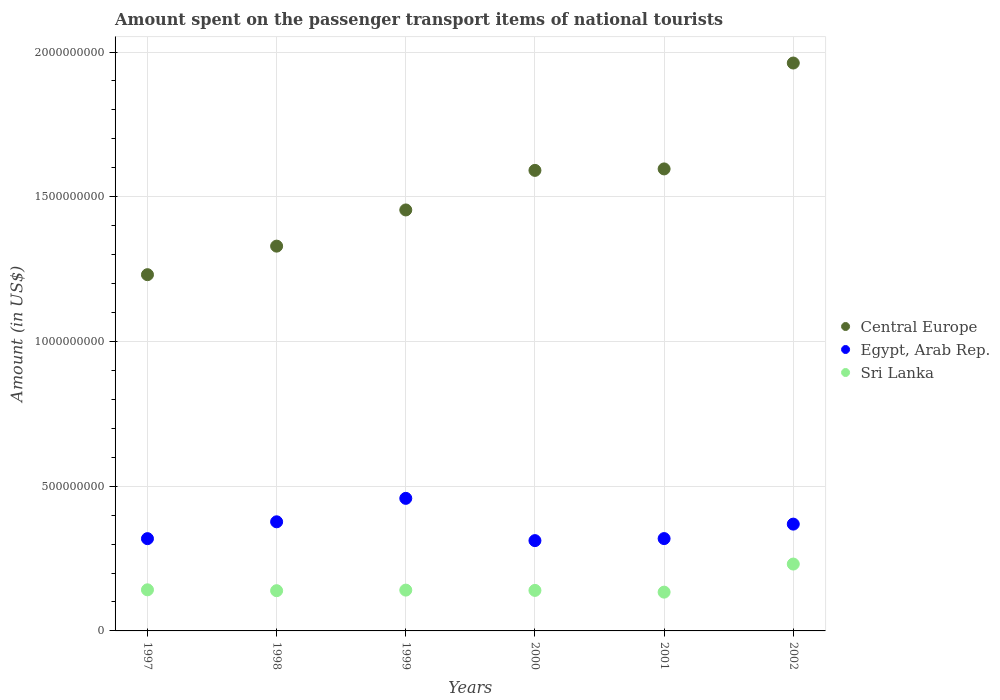How many different coloured dotlines are there?
Provide a succinct answer. 3. Is the number of dotlines equal to the number of legend labels?
Offer a very short reply. Yes. What is the amount spent on the passenger transport items of national tourists in Central Europe in 1999?
Give a very brief answer. 1.45e+09. Across all years, what is the maximum amount spent on the passenger transport items of national tourists in Sri Lanka?
Provide a short and direct response. 2.31e+08. Across all years, what is the minimum amount spent on the passenger transport items of national tourists in Central Europe?
Keep it short and to the point. 1.23e+09. What is the total amount spent on the passenger transport items of national tourists in Sri Lanka in the graph?
Give a very brief answer. 9.27e+08. What is the difference between the amount spent on the passenger transport items of national tourists in Egypt, Arab Rep. in 2000 and that in 2002?
Your answer should be very brief. -5.70e+07. What is the difference between the amount spent on the passenger transport items of national tourists in Egypt, Arab Rep. in 1997 and the amount spent on the passenger transport items of national tourists in Central Europe in 2000?
Your answer should be compact. -1.27e+09. What is the average amount spent on the passenger transport items of national tourists in Sri Lanka per year?
Provide a short and direct response. 1.54e+08. In the year 2001, what is the difference between the amount spent on the passenger transport items of national tourists in Egypt, Arab Rep. and amount spent on the passenger transport items of national tourists in Sri Lanka?
Offer a terse response. 1.85e+08. What is the ratio of the amount spent on the passenger transport items of national tourists in Sri Lanka in 1998 to that in 2000?
Ensure brevity in your answer.  0.99. Is the difference between the amount spent on the passenger transport items of national tourists in Egypt, Arab Rep. in 1998 and 2000 greater than the difference between the amount spent on the passenger transport items of national tourists in Sri Lanka in 1998 and 2000?
Ensure brevity in your answer.  Yes. What is the difference between the highest and the second highest amount spent on the passenger transport items of national tourists in Sri Lanka?
Provide a short and direct response. 8.90e+07. What is the difference between the highest and the lowest amount spent on the passenger transport items of national tourists in Egypt, Arab Rep.?
Make the answer very short. 1.46e+08. Is the sum of the amount spent on the passenger transport items of national tourists in Sri Lanka in 2000 and 2002 greater than the maximum amount spent on the passenger transport items of national tourists in Egypt, Arab Rep. across all years?
Provide a succinct answer. No. Is the amount spent on the passenger transport items of national tourists in Central Europe strictly less than the amount spent on the passenger transport items of national tourists in Egypt, Arab Rep. over the years?
Your answer should be compact. No. How many years are there in the graph?
Provide a short and direct response. 6. Does the graph contain grids?
Keep it short and to the point. Yes. Where does the legend appear in the graph?
Ensure brevity in your answer.  Center right. How many legend labels are there?
Your answer should be very brief. 3. What is the title of the graph?
Provide a short and direct response. Amount spent on the passenger transport items of national tourists. What is the label or title of the X-axis?
Offer a very short reply. Years. What is the label or title of the Y-axis?
Your response must be concise. Amount (in US$). What is the Amount (in US$) in Central Europe in 1997?
Your answer should be compact. 1.23e+09. What is the Amount (in US$) in Egypt, Arab Rep. in 1997?
Your answer should be compact. 3.19e+08. What is the Amount (in US$) in Sri Lanka in 1997?
Your answer should be compact. 1.42e+08. What is the Amount (in US$) in Central Europe in 1998?
Offer a very short reply. 1.33e+09. What is the Amount (in US$) in Egypt, Arab Rep. in 1998?
Offer a very short reply. 3.77e+08. What is the Amount (in US$) of Sri Lanka in 1998?
Your answer should be very brief. 1.39e+08. What is the Amount (in US$) of Central Europe in 1999?
Provide a succinct answer. 1.45e+09. What is the Amount (in US$) in Egypt, Arab Rep. in 1999?
Make the answer very short. 4.58e+08. What is the Amount (in US$) of Sri Lanka in 1999?
Ensure brevity in your answer.  1.41e+08. What is the Amount (in US$) in Central Europe in 2000?
Make the answer very short. 1.59e+09. What is the Amount (in US$) of Egypt, Arab Rep. in 2000?
Your response must be concise. 3.12e+08. What is the Amount (in US$) in Sri Lanka in 2000?
Keep it short and to the point. 1.40e+08. What is the Amount (in US$) of Central Europe in 2001?
Keep it short and to the point. 1.60e+09. What is the Amount (in US$) in Egypt, Arab Rep. in 2001?
Your response must be concise. 3.19e+08. What is the Amount (in US$) of Sri Lanka in 2001?
Offer a very short reply. 1.34e+08. What is the Amount (in US$) in Central Europe in 2002?
Provide a short and direct response. 1.96e+09. What is the Amount (in US$) of Egypt, Arab Rep. in 2002?
Your response must be concise. 3.69e+08. What is the Amount (in US$) in Sri Lanka in 2002?
Keep it short and to the point. 2.31e+08. Across all years, what is the maximum Amount (in US$) in Central Europe?
Your answer should be compact. 1.96e+09. Across all years, what is the maximum Amount (in US$) of Egypt, Arab Rep.?
Provide a succinct answer. 4.58e+08. Across all years, what is the maximum Amount (in US$) of Sri Lanka?
Your response must be concise. 2.31e+08. Across all years, what is the minimum Amount (in US$) of Central Europe?
Make the answer very short. 1.23e+09. Across all years, what is the minimum Amount (in US$) of Egypt, Arab Rep.?
Your answer should be very brief. 3.12e+08. Across all years, what is the minimum Amount (in US$) in Sri Lanka?
Provide a short and direct response. 1.34e+08. What is the total Amount (in US$) of Central Europe in the graph?
Provide a short and direct response. 9.16e+09. What is the total Amount (in US$) of Egypt, Arab Rep. in the graph?
Ensure brevity in your answer.  2.15e+09. What is the total Amount (in US$) of Sri Lanka in the graph?
Your answer should be compact. 9.27e+08. What is the difference between the Amount (in US$) of Central Europe in 1997 and that in 1998?
Provide a succinct answer. -9.86e+07. What is the difference between the Amount (in US$) in Egypt, Arab Rep. in 1997 and that in 1998?
Offer a very short reply. -5.82e+07. What is the difference between the Amount (in US$) of Sri Lanka in 1997 and that in 1998?
Keep it short and to the point. 3.00e+06. What is the difference between the Amount (in US$) in Central Europe in 1997 and that in 1999?
Your answer should be very brief. -2.24e+08. What is the difference between the Amount (in US$) of Egypt, Arab Rep. in 1997 and that in 1999?
Make the answer very short. -1.39e+08. What is the difference between the Amount (in US$) of Sri Lanka in 1997 and that in 1999?
Provide a short and direct response. 1.00e+06. What is the difference between the Amount (in US$) of Central Europe in 1997 and that in 2000?
Give a very brief answer. -3.60e+08. What is the difference between the Amount (in US$) in Egypt, Arab Rep. in 1997 and that in 2000?
Your response must be concise. 6.80e+06. What is the difference between the Amount (in US$) in Central Europe in 1997 and that in 2001?
Offer a terse response. -3.65e+08. What is the difference between the Amount (in US$) of Egypt, Arab Rep. in 1997 and that in 2001?
Ensure brevity in your answer.  -2.00e+05. What is the difference between the Amount (in US$) in Central Europe in 1997 and that in 2002?
Ensure brevity in your answer.  -7.31e+08. What is the difference between the Amount (in US$) in Egypt, Arab Rep. in 1997 and that in 2002?
Give a very brief answer. -5.02e+07. What is the difference between the Amount (in US$) in Sri Lanka in 1997 and that in 2002?
Provide a succinct answer. -8.90e+07. What is the difference between the Amount (in US$) of Central Europe in 1998 and that in 1999?
Offer a terse response. -1.25e+08. What is the difference between the Amount (in US$) of Egypt, Arab Rep. in 1998 and that in 1999?
Offer a very short reply. -8.10e+07. What is the difference between the Amount (in US$) in Sri Lanka in 1998 and that in 1999?
Your answer should be very brief. -2.00e+06. What is the difference between the Amount (in US$) of Central Europe in 1998 and that in 2000?
Your answer should be compact. -2.62e+08. What is the difference between the Amount (in US$) of Egypt, Arab Rep. in 1998 and that in 2000?
Make the answer very short. 6.50e+07. What is the difference between the Amount (in US$) of Sri Lanka in 1998 and that in 2000?
Ensure brevity in your answer.  -1.00e+06. What is the difference between the Amount (in US$) of Central Europe in 1998 and that in 2001?
Offer a very short reply. -2.67e+08. What is the difference between the Amount (in US$) of Egypt, Arab Rep. in 1998 and that in 2001?
Your response must be concise. 5.80e+07. What is the difference between the Amount (in US$) in Central Europe in 1998 and that in 2002?
Offer a very short reply. -6.33e+08. What is the difference between the Amount (in US$) of Sri Lanka in 1998 and that in 2002?
Your answer should be very brief. -9.20e+07. What is the difference between the Amount (in US$) of Central Europe in 1999 and that in 2000?
Ensure brevity in your answer.  -1.37e+08. What is the difference between the Amount (in US$) of Egypt, Arab Rep. in 1999 and that in 2000?
Offer a terse response. 1.46e+08. What is the difference between the Amount (in US$) of Central Europe in 1999 and that in 2001?
Ensure brevity in your answer.  -1.42e+08. What is the difference between the Amount (in US$) of Egypt, Arab Rep. in 1999 and that in 2001?
Provide a succinct answer. 1.39e+08. What is the difference between the Amount (in US$) of Sri Lanka in 1999 and that in 2001?
Make the answer very short. 7.00e+06. What is the difference between the Amount (in US$) in Central Europe in 1999 and that in 2002?
Your answer should be compact. -5.08e+08. What is the difference between the Amount (in US$) in Egypt, Arab Rep. in 1999 and that in 2002?
Provide a short and direct response. 8.90e+07. What is the difference between the Amount (in US$) of Sri Lanka in 1999 and that in 2002?
Your answer should be compact. -9.00e+07. What is the difference between the Amount (in US$) of Central Europe in 2000 and that in 2001?
Keep it short and to the point. -5.06e+06. What is the difference between the Amount (in US$) in Egypt, Arab Rep. in 2000 and that in 2001?
Your response must be concise. -7.00e+06. What is the difference between the Amount (in US$) in Sri Lanka in 2000 and that in 2001?
Offer a terse response. 6.00e+06. What is the difference between the Amount (in US$) of Central Europe in 2000 and that in 2002?
Provide a short and direct response. -3.71e+08. What is the difference between the Amount (in US$) in Egypt, Arab Rep. in 2000 and that in 2002?
Your response must be concise. -5.70e+07. What is the difference between the Amount (in US$) of Sri Lanka in 2000 and that in 2002?
Your response must be concise. -9.10e+07. What is the difference between the Amount (in US$) in Central Europe in 2001 and that in 2002?
Provide a succinct answer. -3.66e+08. What is the difference between the Amount (in US$) in Egypt, Arab Rep. in 2001 and that in 2002?
Your answer should be compact. -5.00e+07. What is the difference between the Amount (in US$) of Sri Lanka in 2001 and that in 2002?
Your answer should be compact. -9.70e+07. What is the difference between the Amount (in US$) of Central Europe in 1997 and the Amount (in US$) of Egypt, Arab Rep. in 1998?
Provide a short and direct response. 8.54e+08. What is the difference between the Amount (in US$) in Central Europe in 1997 and the Amount (in US$) in Sri Lanka in 1998?
Ensure brevity in your answer.  1.09e+09. What is the difference between the Amount (in US$) of Egypt, Arab Rep. in 1997 and the Amount (in US$) of Sri Lanka in 1998?
Your answer should be very brief. 1.80e+08. What is the difference between the Amount (in US$) of Central Europe in 1997 and the Amount (in US$) of Egypt, Arab Rep. in 1999?
Keep it short and to the point. 7.73e+08. What is the difference between the Amount (in US$) of Central Europe in 1997 and the Amount (in US$) of Sri Lanka in 1999?
Keep it short and to the point. 1.09e+09. What is the difference between the Amount (in US$) of Egypt, Arab Rep. in 1997 and the Amount (in US$) of Sri Lanka in 1999?
Keep it short and to the point. 1.78e+08. What is the difference between the Amount (in US$) of Central Europe in 1997 and the Amount (in US$) of Egypt, Arab Rep. in 2000?
Provide a short and direct response. 9.19e+08. What is the difference between the Amount (in US$) in Central Europe in 1997 and the Amount (in US$) in Sri Lanka in 2000?
Provide a succinct answer. 1.09e+09. What is the difference between the Amount (in US$) in Egypt, Arab Rep. in 1997 and the Amount (in US$) in Sri Lanka in 2000?
Make the answer very short. 1.79e+08. What is the difference between the Amount (in US$) in Central Europe in 1997 and the Amount (in US$) in Egypt, Arab Rep. in 2001?
Your response must be concise. 9.12e+08. What is the difference between the Amount (in US$) in Central Europe in 1997 and the Amount (in US$) in Sri Lanka in 2001?
Offer a very short reply. 1.10e+09. What is the difference between the Amount (in US$) in Egypt, Arab Rep. in 1997 and the Amount (in US$) in Sri Lanka in 2001?
Offer a very short reply. 1.85e+08. What is the difference between the Amount (in US$) in Central Europe in 1997 and the Amount (in US$) in Egypt, Arab Rep. in 2002?
Provide a succinct answer. 8.62e+08. What is the difference between the Amount (in US$) of Central Europe in 1997 and the Amount (in US$) of Sri Lanka in 2002?
Provide a succinct answer. 1.00e+09. What is the difference between the Amount (in US$) of Egypt, Arab Rep. in 1997 and the Amount (in US$) of Sri Lanka in 2002?
Keep it short and to the point. 8.78e+07. What is the difference between the Amount (in US$) in Central Europe in 1998 and the Amount (in US$) in Egypt, Arab Rep. in 1999?
Offer a terse response. 8.71e+08. What is the difference between the Amount (in US$) of Central Europe in 1998 and the Amount (in US$) of Sri Lanka in 1999?
Give a very brief answer. 1.19e+09. What is the difference between the Amount (in US$) in Egypt, Arab Rep. in 1998 and the Amount (in US$) in Sri Lanka in 1999?
Provide a succinct answer. 2.36e+08. What is the difference between the Amount (in US$) of Central Europe in 1998 and the Amount (in US$) of Egypt, Arab Rep. in 2000?
Give a very brief answer. 1.02e+09. What is the difference between the Amount (in US$) of Central Europe in 1998 and the Amount (in US$) of Sri Lanka in 2000?
Give a very brief answer. 1.19e+09. What is the difference between the Amount (in US$) of Egypt, Arab Rep. in 1998 and the Amount (in US$) of Sri Lanka in 2000?
Make the answer very short. 2.37e+08. What is the difference between the Amount (in US$) in Central Europe in 1998 and the Amount (in US$) in Egypt, Arab Rep. in 2001?
Your response must be concise. 1.01e+09. What is the difference between the Amount (in US$) in Central Europe in 1998 and the Amount (in US$) in Sri Lanka in 2001?
Ensure brevity in your answer.  1.20e+09. What is the difference between the Amount (in US$) in Egypt, Arab Rep. in 1998 and the Amount (in US$) in Sri Lanka in 2001?
Offer a terse response. 2.43e+08. What is the difference between the Amount (in US$) in Central Europe in 1998 and the Amount (in US$) in Egypt, Arab Rep. in 2002?
Give a very brief answer. 9.60e+08. What is the difference between the Amount (in US$) of Central Europe in 1998 and the Amount (in US$) of Sri Lanka in 2002?
Offer a terse response. 1.10e+09. What is the difference between the Amount (in US$) of Egypt, Arab Rep. in 1998 and the Amount (in US$) of Sri Lanka in 2002?
Make the answer very short. 1.46e+08. What is the difference between the Amount (in US$) in Central Europe in 1999 and the Amount (in US$) in Egypt, Arab Rep. in 2000?
Offer a very short reply. 1.14e+09. What is the difference between the Amount (in US$) in Central Europe in 1999 and the Amount (in US$) in Sri Lanka in 2000?
Provide a succinct answer. 1.31e+09. What is the difference between the Amount (in US$) in Egypt, Arab Rep. in 1999 and the Amount (in US$) in Sri Lanka in 2000?
Make the answer very short. 3.18e+08. What is the difference between the Amount (in US$) in Central Europe in 1999 and the Amount (in US$) in Egypt, Arab Rep. in 2001?
Make the answer very short. 1.14e+09. What is the difference between the Amount (in US$) of Central Europe in 1999 and the Amount (in US$) of Sri Lanka in 2001?
Ensure brevity in your answer.  1.32e+09. What is the difference between the Amount (in US$) in Egypt, Arab Rep. in 1999 and the Amount (in US$) in Sri Lanka in 2001?
Ensure brevity in your answer.  3.24e+08. What is the difference between the Amount (in US$) of Central Europe in 1999 and the Amount (in US$) of Egypt, Arab Rep. in 2002?
Offer a very short reply. 1.09e+09. What is the difference between the Amount (in US$) of Central Europe in 1999 and the Amount (in US$) of Sri Lanka in 2002?
Offer a very short reply. 1.22e+09. What is the difference between the Amount (in US$) of Egypt, Arab Rep. in 1999 and the Amount (in US$) of Sri Lanka in 2002?
Your answer should be very brief. 2.27e+08. What is the difference between the Amount (in US$) in Central Europe in 2000 and the Amount (in US$) in Egypt, Arab Rep. in 2001?
Ensure brevity in your answer.  1.27e+09. What is the difference between the Amount (in US$) in Central Europe in 2000 and the Amount (in US$) in Sri Lanka in 2001?
Keep it short and to the point. 1.46e+09. What is the difference between the Amount (in US$) in Egypt, Arab Rep. in 2000 and the Amount (in US$) in Sri Lanka in 2001?
Your response must be concise. 1.78e+08. What is the difference between the Amount (in US$) in Central Europe in 2000 and the Amount (in US$) in Egypt, Arab Rep. in 2002?
Give a very brief answer. 1.22e+09. What is the difference between the Amount (in US$) in Central Europe in 2000 and the Amount (in US$) in Sri Lanka in 2002?
Offer a terse response. 1.36e+09. What is the difference between the Amount (in US$) of Egypt, Arab Rep. in 2000 and the Amount (in US$) of Sri Lanka in 2002?
Give a very brief answer. 8.10e+07. What is the difference between the Amount (in US$) of Central Europe in 2001 and the Amount (in US$) of Egypt, Arab Rep. in 2002?
Offer a very short reply. 1.23e+09. What is the difference between the Amount (in US$) in Central Europe in 2001 and the Amount (in US$) in Sri Lanka in 2002?
Your response must be concise. 1.37e+09. What is the difference between the Amount (in US$) in Egypt, Arab Rep. in 2001 and the Amount (in US$) in Sri Lanka in 2002?
Keep it short and to the point. 8.80e+07. What is the average Amount (in US$) of Central Europe per year?
Make the answer very short. 1.53e+09. What is the average Amount (in US$) of Egypt, Arab Rep. per year?
Provide a succinct answer. 3.59e+08. What is the average Amount (in US$) in Sri Lanka per year?
Give a very brief answer. 1.54e+08. In the year 1997, what is the difference between the Amount (in US$) in Central Europe and Amount (in US$) in Egypt, Arab Rep.?
Provide a short and direct response. 9.12e+08. In the year 1997, what is the difference between the Amount (in US$) of Central Europe and Amount (in US$) of Sri Lanka?
Your response must be concise. 1.09e+09. In the year 1997, what is the difference between the Amount (in US$) of Egypt, Arab Rep. and Amount (in US$) of Sri Lanka?
Provide a succinct answer. 1.77e+08. In the year 1998, what is the difference between the Amount (in US$) in Central Europe and Amount (in US$) in Egypt, Arab Rep.?
Your answer should be very brief. 9.52e+08. In the year 1998, what is the difference between the Amount (in US$) in Central Europe and Amount (in US$) in Sri Lanka?
Your answer should be very brief. 1.19e+09. In the year 1998, what is the difference between the Amount (in US$) in Egypt, Arab Rep. and Amount (in US$) in Sri Lanka?
Give a very brief answer. 2.38e+08. In the year 1999, what is the difference between the Amount (in US$) in Central Europe and Amount (in US$) in Egypt, Arab Rep.?
Make the answer very short. 9.96e+08. In the year 1999, what is the difference between the Amount (in US$) in Central Europe and Amount (in US$) in Sri Lanka?
Offer a very short reply. 1.31e+09. In the year 1999, what is the difference between the Amount (in US$) in Egypt, Arab Rep. and Amount (in US$) in Sri Lanka?
Your answer should be very brief. 3.17e+08. In the year 2000, what is the difference between the Amount (in US$) of Central Europe and Amount (in US$) of Egypt, Arab Rep.?
Offer a very short reply. 1.28e+09. In the year 2000, what is the difference between the Amount (in US$) in Central Europe and Amount (in US$) in Sri Lanka?
Your answer should be compact. 1.45e+09. In the year 2000, what is the difference between the Amount (in US$) of Egypt, Arab Rep. and Amount (in US$) of Sri Lanka?
Your answer should be compact. 1.72e+08. In the year 2001, what is the difference between the Amount (in US$) of Central Europe and Amount (in US$) of Egypt, Arab Rep.?
Provide a short and direct response. 1.28e+09. In the year 2001, what is the difference between the Amount (in US$) in Central Europe and Amount (in US$) in Sri Lanka?
Your answer should be compact. 1.46e+09. In the year 2001, what is the difference between the Amount (in US$) in Egypt, Arab Rep. and Amount (in US$) in Sri Lanka?
Give a very brief answer. 1.85e+08. In the year 2002, what is the difference between the Amount (in US$) in Central Europe and Amount (in US$) in Egypt, Arab Rep.?
Ensure brevity in your answer.  1.59e+09. In the year 2002, what is the difference between the Amount (in US$) in Central Europe and Amount (in US$) in Sri Lanka?
Make the answer very short. 1.73e+09. In the year 2002, what is the difference between the Amount (in US$) in Egypt, Arab Rep. and Amount (in US$) in Sri Lanka?
Provide a short and direct response. 1.38e+08. What is the ratio of the Amount (in US$) of Central Europe in 1997 to that in 1998?
Offer a very short reply. 0.93. What is the ratio of the Amount (in US$) in Egypt, Arab Rep. in 1997 to that in 1998?
Offer a very short reply. 0.85. What is the ratio of the Amount (in US$) of Sri Lanka in 1997 to that in 1998?
Provide a short and direct response. 1.02. What is the ratio of the Amount (in US$) of Central Europe in 1997 to that in 1999?
Your response must be concise. 0.85. What is the ratio of the Amount (in US$) in Egypt, Arab Rep. in 1997 to that in 1999?
Make the answer very short. 0.7. What is the ratio of the Amount (in US$) of Sri Lanka in 1997 to that in 1999?
Your answer should be compact. 1.01. What is the ratio of the Amount (in US$) in Central Europe in 1997 to that in 2000?
Your response must be concise. 0.77. What is the ratio of the Amount (in US$) in Egypt, Arab Rep. in 1997 to that in 2000?
Provide a short and direct response. 1.02. What is the ratio of the Amount (in US$) in Sri Lanka in 1997 to that in 2000?
Keep it short and to the point. 1.01. What is the ratio of the Amount (in US$) of Central Europe in 1997 to that in 2001?
Offer a very short reply. 0.77. What is the ratio of the Amount (in US$) in Sri Lanka in 1997 to that in 2001?
Provide a short and direct response. 1.06. What is the ratio of the Amount (in US$) of Central Europe in 1997 to that in 2002?
Give a very brief answer. 0.63. What is the ratio of the Amount (in US$) in Egypt, Arab Rep. in 1997 to that in 2002?
Keep it short and to the point. 0.86. What is the ratio of the Amount (in US$) in Sri Lanka in 1997 to that in 2002?
Provide a short and direct response. 0.61. What is the ratio of the Amount (in US$) of Central Europe in 1998 to that in 1999?
Your answer should be compact. 0.91. What is the ratio of the Amount (in US$) in Egypt, Arab Rep. in 1998 to that in 1999?
Provide a succinct answer. 0.82. What is the ratio of the Amount (in US$) of Sri Lanka in 1998 to that in 1999?
Keep it short and to the point. 0.99. What is the ratio of the Amount (in US$) in Central Europe in 1998 to that in 2000?
Ensure brevity in your answer.  0.84. What is the ratio of the Amount (in US$) in Egypt, Arab Rep. in 1998 to that in 2000?
Provide a short and direct response. 1.21. What is the ratio of the Amount (in US$) of Sri Lanka in 1998 to that in 2000?
Keep it short and to the point. 0.99. What is the ratio of the Amount (in US$) of Central Europe in 1998 to that in 2001?
Provide a succinct answer. 0.83. What is the ratio of the Amount (in US$) of Egypt, Arab Rep. in 1998 to that in 2001?
Provide a short and direct response. 1.18. What is the ratio of the Amount (in US$) in Sri Lanka in 1998 to that in 2001?
Give a very brief answer. 1.04. What is the ratio of the Amount (in US$) of Central Europe in 1998 to that in 2002?
Your answer should be very brief. 0.68. What is the ratio of the Amount (in US$) of Egypt, Arab Rep. in 1998 to that in 2002?
Offer a terse response. 1.02. What is the ratio of the Amount (in US$) in Sri Lanka in 1998 to that in 2002?
Ensure brevity in your answer.  0.6. What is the ratio of the Amount (in US$) of Central Europe in 1999 to that in 2000?
Provide a succinct answer. 0.91. What is the ratio of the Amount (in US$) of Egypt, Arab Rep. in 1999 to that in 2000?
Provide a succinct answer. 1.47. What is the ratio of the Amount (in US$) of Sri Lanka in 1999 to that in 2000?
Provide a succinct answer. 1.01. What is the ratio of the Amount (in US$) of Central Europe in 1999 to that in 2001?
Your answer should be compact. 0.91. What is the ratio of the Amount (in US$) in Egypt, Arab Rep. in 1999 to that in 2001?
Your response must be concise. 1.44. What is the ratio of the Amount (in US$) of Sri Lanka in 1999 to that in 2001?
Provide a short and direct response. 1.05. What is the ratio of the Amount (in US$) of Central Europe in 1999 to that in 2002?
Provide a short and direct response. 0.74. What is the ratio of the Amount (in US$) of Egypt, Arab Rep. in 1999 to that in 2002?
Make the answer very short. 1.24. What is the ratio of the Amount (in US$) in Sri Lanka in 1999 to that in 2002?
Provide a short and direct response. 0.61. What is the ratio of the Amount (in US$) of Central Europe in 2000 to that in 2001?
Ensure brevity in your answer.  1. What is the ratio of the Amount (in US$) of Egypt, Arab Rep. in 2000 to that in 2001?
Your answer should be very brief. 0.98. What is the ratio of the Amount (in US$) in Sri Lanka in 2000 to that in 2001?
Keep it short and to the point. 1.04. What is the ratio of the Amount (in US$) in Central Europe in 2000 to that in 2002?
Provide a succinct answer. 0.81. What is the ratio of the Amount (in US$) in Egypt, Arab Rep. in 2000 to that in 2002?
Give a very brief answer. 0.85. What is the ratio of the Amount (in US$) of Sri Lanka in 2000 to that in 2002?
Your answer should be very brief. 0.61. What is the ratio of the Amount (in US$) in Central Europe in 2001 to that in 2002?
Provide a succinct answer. 0.81. What is the ratio of the Amount (in US$) of Egypt, Arab Rep. in 2001 to that in 2002?
Your answer should be compact. 0.86. What is the ratio of the Amount (in US$) of Sri Lanka in 2001 to that in 2002?
Keep it short and to the point. 0.58. What is the difference between the highest and the second highest Amount (in US$) of Central Europe?
Ensure brevity in your answer.  3.66e+08. What is the difference between the highest and the second highest Amount (in US$) in Egypt, Arab Rep.?
Keep it short and to the point. 8.10e+07. What is the difference between the highest and the second highest Amount (in US$) in Sri Lanka?
Provide a short and direct response. 8.90e+07. What is the difference between the highest and the lowest Amount (in US$) of Central Europe?
Give a very brief answer. 7.31e+08. What is the difference between the highest and the lowest Amount (in US$) in Egypt, Arab Rep.?
Your response must be concise. 1.46e+08. What is the difference between the highest and the lowest Amount (in US$) in Sri Lanka?
Your response must be concise. 9.70e+07. 